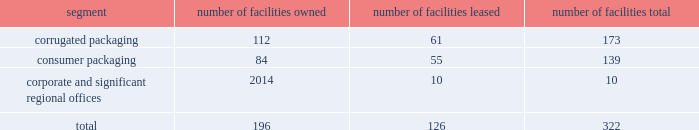Consume significant amounts of energy , and we may in the future incur additional or increased capital , operating and other expenditures from changes due to new or increased climate-related and other environmental regulations .
We could also incur substantial liabilities , including fines or sanctions , enforcement actions , natural resource damages claims , cleanup and closure costs , and third-party claims for property damage and personal injury under environmental and common laws .
The foreign corrupt practices act of 1977 and local anti-bribery laws , including those in brazil , china , mexico , india and the united kingdom ( where we maintain operations directly or through a joint venture ) , prohibit companies and their intermediaries from making improper payments to government officials for the purpose of influencing official decisions .
Our internal control policies and procedures , or those of our vendors , may not adequately protect us from reckless or criminal acts committed or alleged to have been committed by our employees , agents or vendors .
Any such violations could lead to civil or criminal monetary and non-monetary penalties and/or could damage our reputation .
We are subject to a number of labor and employment laws and regulations that could significantly increase our operating costs and reduce our operational flexibility .
Additionally , changing privacy laws in the united states ( including the california consumer privacy act , which will become effective in january 2020 ) , europe ( where the general data protection regulation became effective in 2018 ) and elsewhere have created new individual privacy rights , imposed increased obligations on companies handling personal data and increased potential exposure to fines and penalties .
Item 1b .
Unresolved staff comments there are no unresolved sec staff comments .
Item 2 .
Properties we operate locations in north america , including the majority of u.s .
States , south america , europe , asia and australia .
We lease our principal offices in atlanta , ga .
We believe that our existing production capacity is adequate to serve existing demand for our products and consider our plants and equipment to be in good condition .
Our corporate and operating facilities as of september 30 , 2019 are summarized below: .
The tables that follow show our annual production capacity by mill at september 30 , 2019 in thousands of tons , except for the north charleston , sc mill which reflects our capacity after the previously announced machine closure expected to occur in fiscal 2020 .
Our mill system production levels and operating rates may vary from year to year due to changes in market and other factors , including the impact of hurricanes and other weather-related events .
Our simple average mill system operating rates for the last three years averaged 94% ( 94 % ) .
We own all of our mills. .
What percent of facilities are for consumer packaging? 
Computations: (139 / 322)
Answer: 0.43168. 